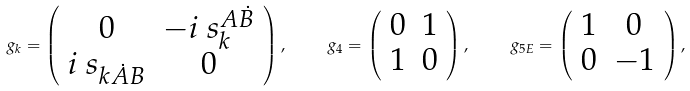Convert formula to latex. <formula><loc_0><loc_0><loc_500><loc_500>\ g _ { k } = \left ( \begin{array} { c c } 0 & - i \ s _ { k } ^ { A \dot { B } } \\ i \ s _ { k \dot { A } B } & 0 \\ \end{array} \right ) , \quad \ g _ { 4 } = \left ( \begin{array} { c c } 0 & 1 \\ 1 & 0 \\ \end{array} \right ) , \quad \ g _ { 5 E } = \left ( \begin{array} { c c } 1 & 0 \\ 0 & - 1 \\ \end{array} \right ) ,</formula> 